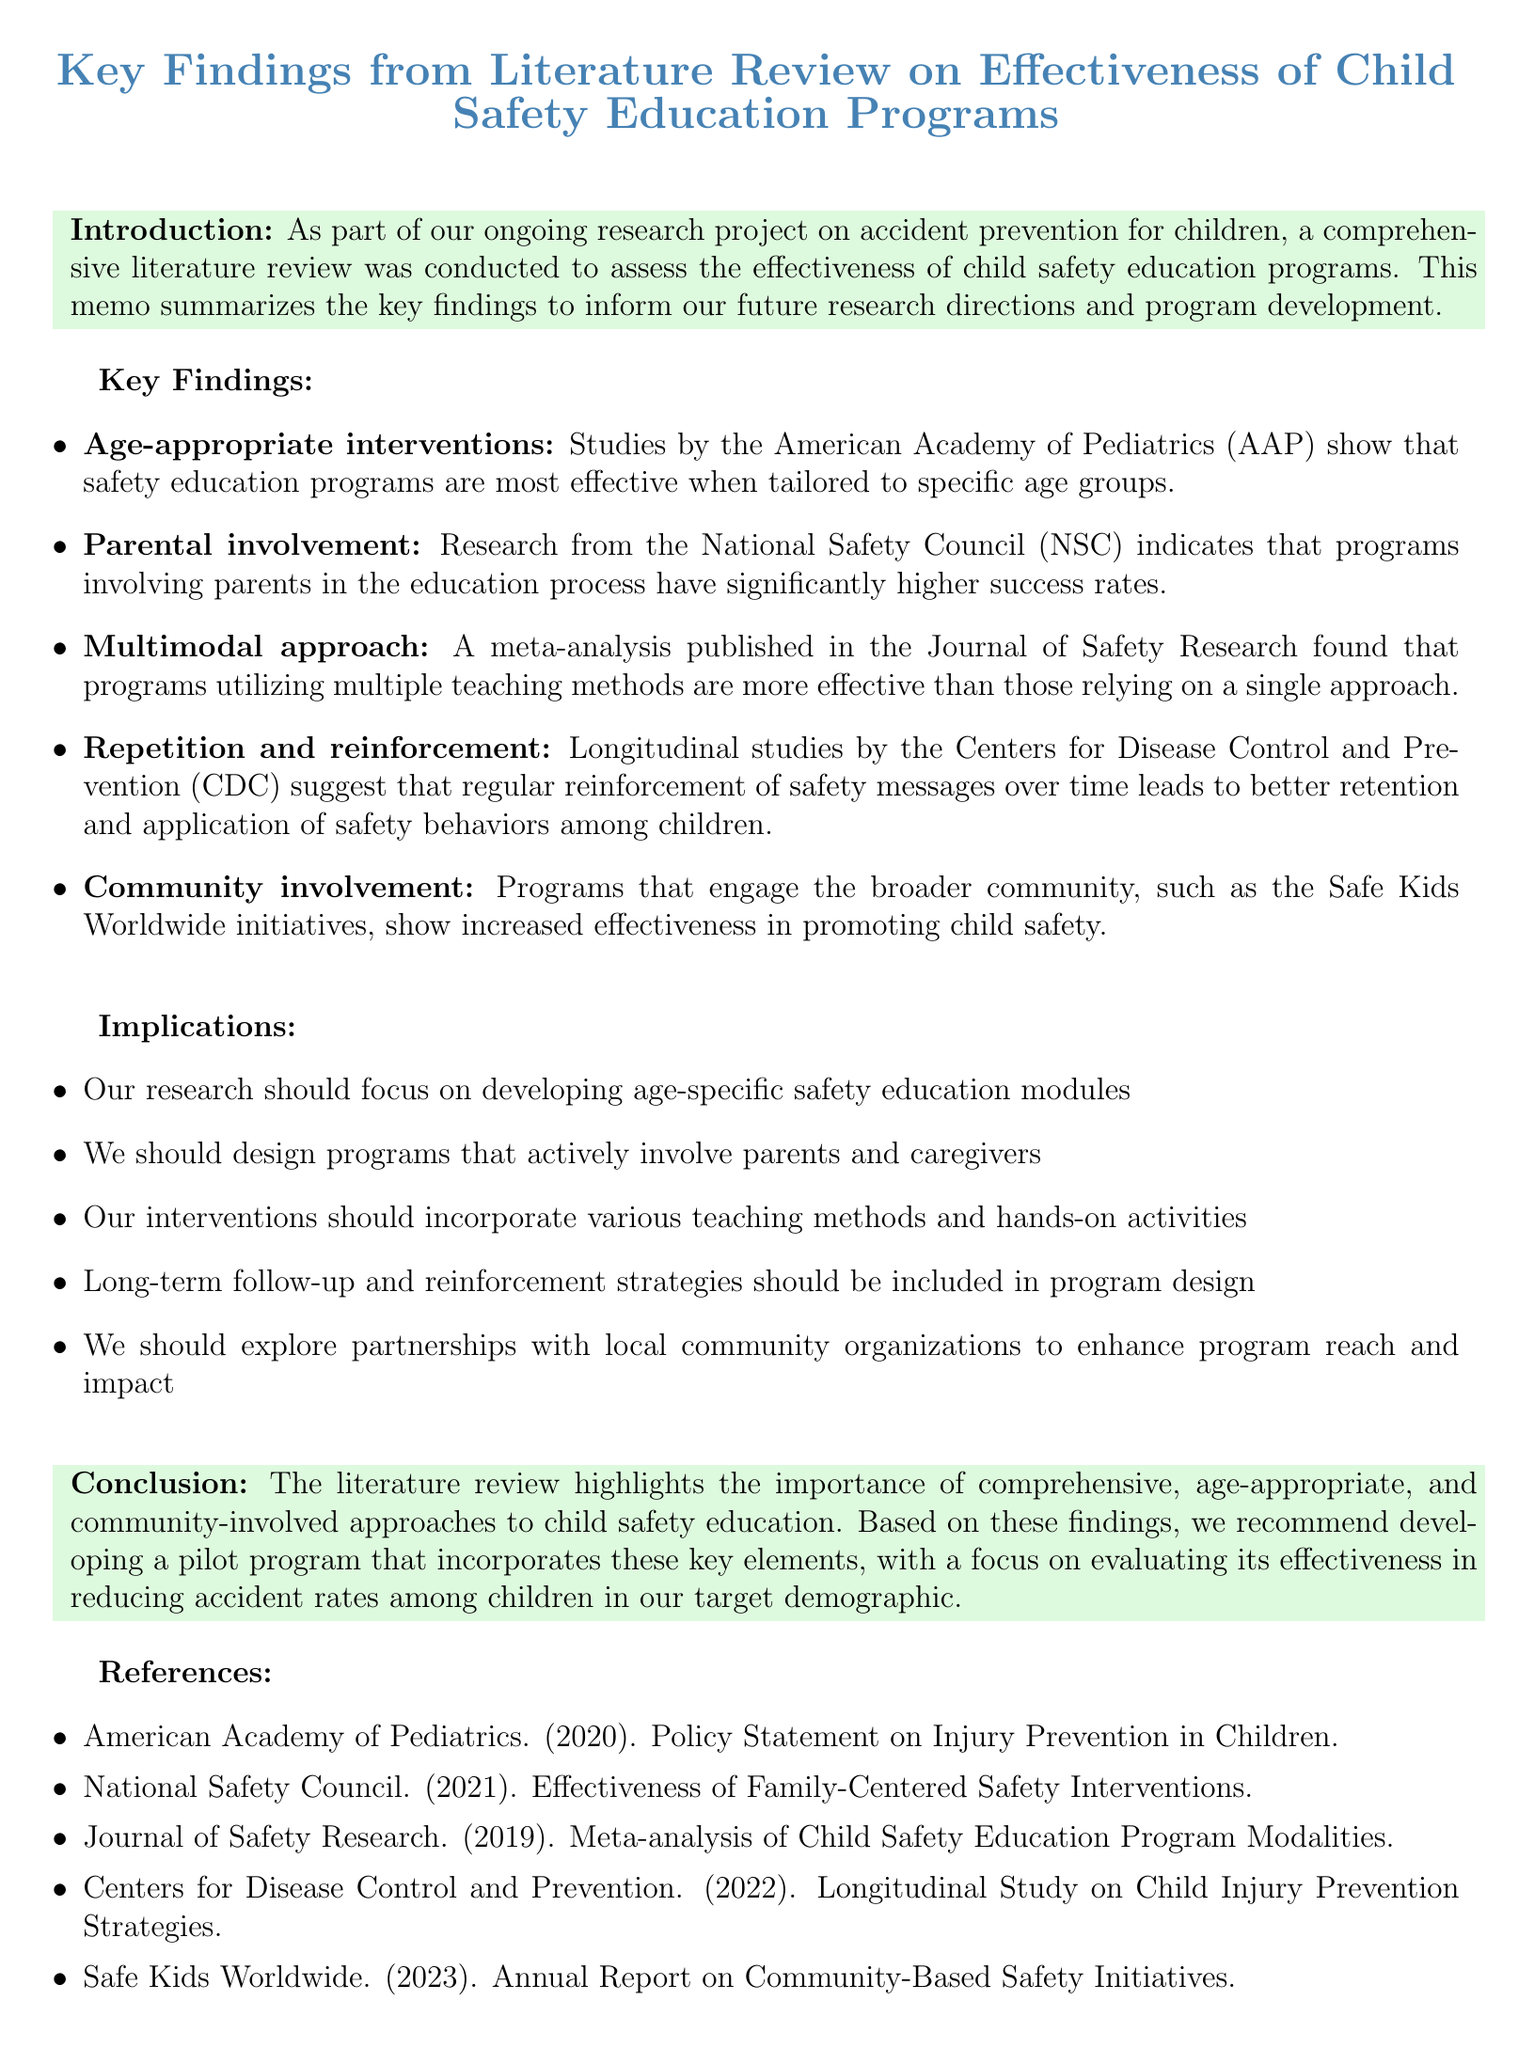what is the title of the memo? The title of the memo summarizes the findings from the literature review on child safety education programs.
Answer: Key Findings from Literature Review on Effectiveness of Child Safety Education Programs what are the sources of the key findings? The sources mentioned in the memo include studies and research from organizations such as AAP, NSC, CDC, and more.
Answer: American Academy of Pediatrics, National Safety Council, Centers for Disease Control and Prevention, Journal of Safety Research, Safe Kids Worldwide which age group is mentioned in the key findings? The memo mentions that safety education programs should be tailored to specific age groups, including preschoolers.
Answer: preschoolers what is the implication regarding parental involvement? The memo states that programs should actively involve parents and caregivers in the education process.
Answer: design programs that actively involve parents and caregivers what type of teaching methods does the memo advocate for? The memo emphasizes utilizing multiple teaching methods for effectiveness in safety education programs.
Answer: various teaching methods which organization conducted the longitudinal studies mentioned? The memo references longitudinal studies conducted by a specific organization that studies child injury prevention.
Answer: Centers for Disease Control and Prevention what is the conclusion about community involvement? The memo concludes that community involvement is essential in promoting child safety effectively.
Answer: importance of comprehensive, age-appropriate, and community-involved approaches which year was the policy statement on injury prevention published? The memo lists a reference to a policy statement from the American Academy of Pediatrics with a specific publication year.
Answer: 2020 